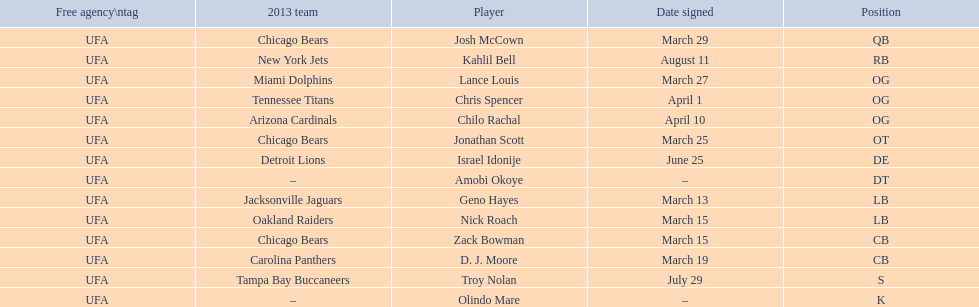How many players play cb or og? 5. Write the full table. {'header': ['Free agency\\ntag', '2013 team', 'Player', 'Date signed', 'Position'], 'rows': [['UFA', 'Chicago Bears', 'Josh McCown', 'March 29', 'QB'], ['UFA', 'New York Jets', 'Kahlil Bell', 'August 11', 'RB'], ['UFA', 'Miami Dolphins', 'Lance Louis', 'March 27', 'OG'], ['UFA', 'Tennessee Titans', 'Chris Spencer', 'April 1', 'OG'], ['UFA', 'Arizona Cardinals', 'Chilo Rachal', 'April 10', 'OG'], ['UFA', 'Chicago Bears', 'Jonathan Scott', 'March 25', 'OT'], ['UFA', 'Detroit Lions', 'Israel Idonije', 'June 25', 'DE'], ['UFA', '–', 'Amobi Okoye', '–', 'DT'], ['UFA', 'Jacksonville Jaguars', 'Geno Hayes', 'March 13', 'LB'], ['UFA', 'Oakland Raiders', 'Nick Roach', 'March 15', 'LB'], ['UFA', 'Chicago Bears', 'Zack Bowman', 'March 15', 'CB'], ['UFA', 'Carolina Panthers', 'D. J. Moore', 'March 19', 'CB'], ['UFA', 'Tampa Bay Buccaneers', 'Troy Nolan', 'July 29', 'S'], ['UFA', '–', 'Olindo Mare', '–', 'K']]} 